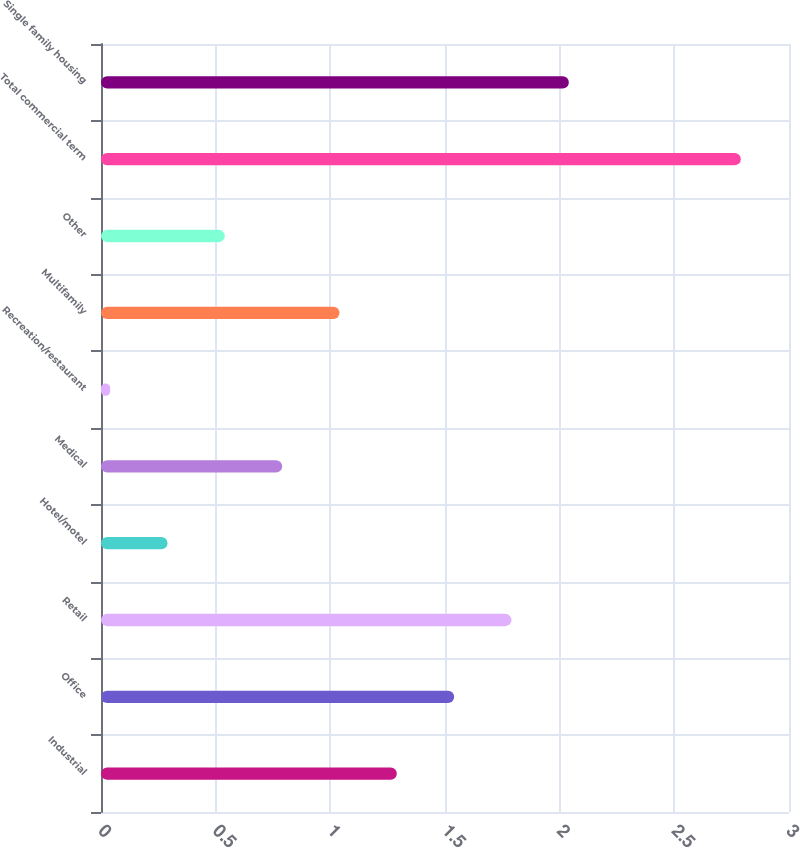<chart> <loc_0><loc_0><loc_500><loc_500><bar_chart><fcel>Industrial<fcel>Office<fcel>Retail<fcel>Hotel/motel<fcel>Medical<fcel>Recreation/restaurant<fcel>Multifamily<fcel>Other<fcel>Total commercial term<fcel>Single family housing<nl><fcel>1.29<fcel>1.54<fcel>1.79<fcel>0.29<fcel>0.79<fcel>0.04<fcel>1.04<fcel>0.54<fcel>2.79<fcel>2.04<nl></chart> 